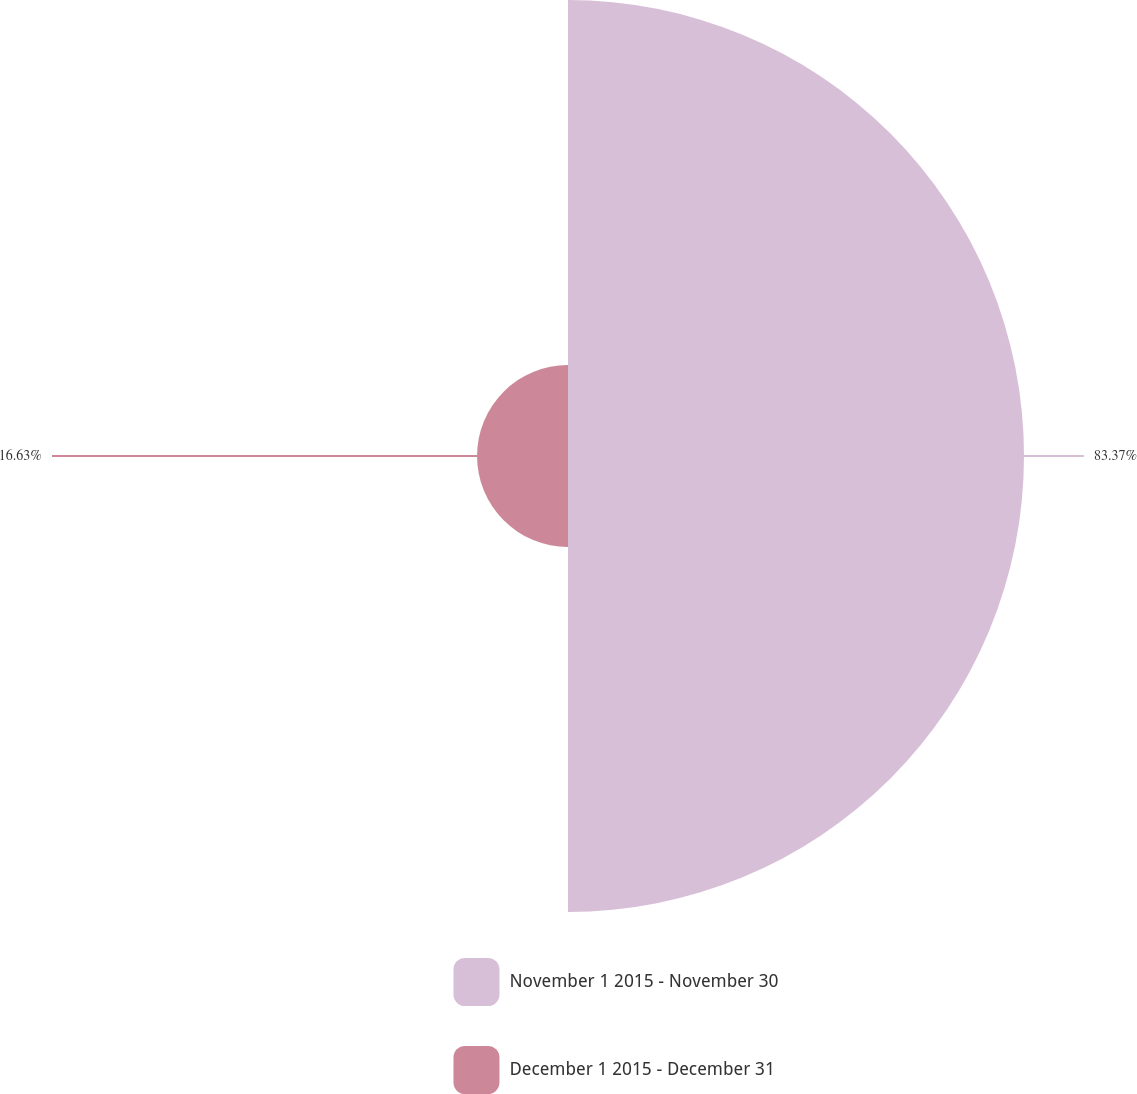Convert chart. <chart><loc_0><loc_0><loc_500><loc_500><pie_chart><fcel>November 1 2015 - November 30<fcel>December 1 2015 - December 31<nl><fcel>83.37%<fcel>16.63%<nl></chart> 